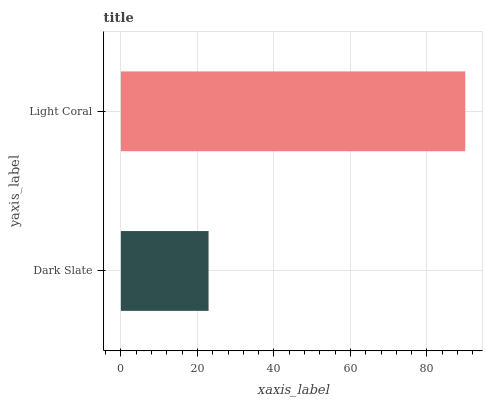Is Dark Slate the minimum?
Answer yes or no. Yes. Is Light Coral the maximum?
Answer yes or no. Yes. Is Light Coral the minimum?
Answer yes or no. No. Is Light Coral greater than Dark Slate?
Answer yes or no. Yes. Is Dark Slate less than Light Coral?
Answer yes or no. Yes. Is Dark Slate greater than Light Coral?
Answer yes or no. No. Is Light Coral less than Dark Slate?
Answer yes or no. No. Is Light Coral the high median?
Answer yes or no. Yes. Is Dark Slate the low median?
Answer yes or no. Yes. Is Dark Slate the high median?
Answer yes or no. No. Is Light Coral the low median?
Answer yes or no. No. 